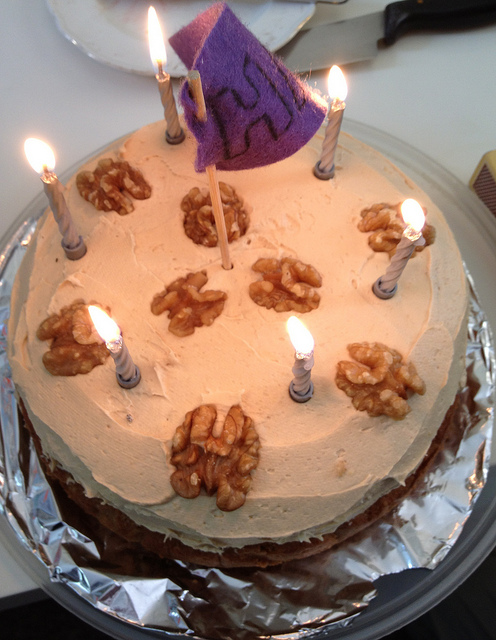Identify and read out the text in this image. H 